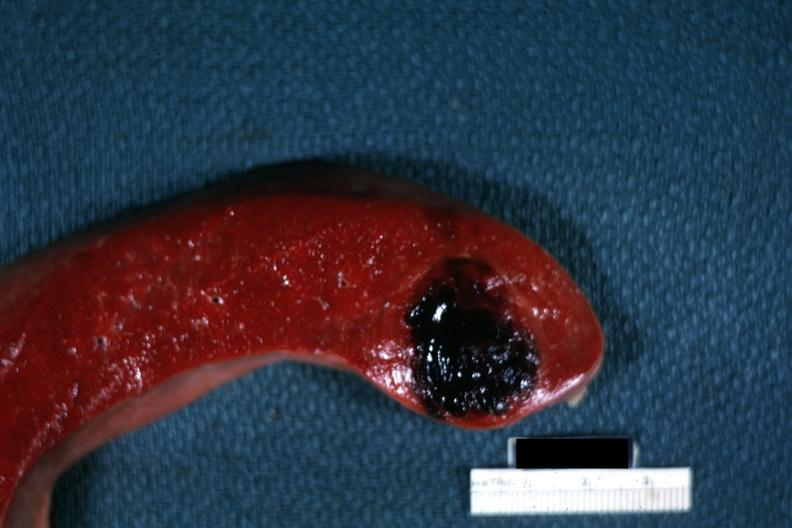s hematologic present?
Answer the question using a single word or phrase. Yes 